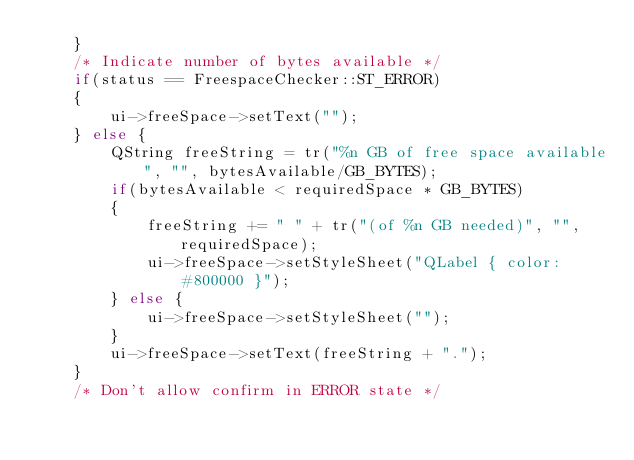<code> <loc_0><loc_0><loc_500><loc_500><_C++_>    }
    /* Indicate number of bytes available */
    if(status == FreespaceChecker::ST_ERROR)
    {
        ui->freeSpace->setText("");
    } else {
        QString freeString = tr("%n GB of free space available", "", bytesAvailable/GB_BYTES);
        if(bytesAvailable < requiredSpace * GB_BYTES)
        {
            freeString += " " + tr("(of %n GB needed)", "", requiredSpace);
            ui->freeSpace->setStyleSheet("QLabel { color: #800000 }");
        } else {
            ui->freeSpace->setStyleSheet("");
        }
        ui->freeSpace->setText(freeString + ".");
    }
    /* Don't allow confirm in ERROR state */</code> 